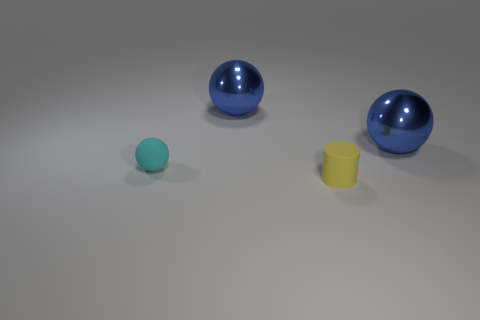There is a thing that is both behind the small cyan matte sphere and to the left of the small matte cylinder; what is it made of?
Your answer should be compact. Metal. Do the object in front of the cyan object and the cyan rubber ball have the same size?
Offer a very short reply. Yes. Does the matte cylinder have the same color as the small rubber sphere?
Provide a succinct answer. No. What number of objects are both to the left of the cylinder and behind the small cyan object?
Give a very brief answer. 1. What number of big metallic things are in front of the small thing that is in front of the small ball left of the tiny yellow matte cylinder?
Your answer should be compact. 0. The yellow rubber thing has what shape?
Offer a terse response. Cylinder. How many small cyan things are made of the same material as the yellow cylinder?
Provide a short and direct response. 1. There is a object that is the same material as the cylinder; what color is it?
Ensure brevity in your answer.  Cyan. Is the size of the cyan rubber ball the same as the matte thing that is on the right side of the tiny matte sphere?
Your answer should be compact. Yes. There is a blue object to the right of the big thing that is on the left side of the thing that is in front of the small cyan matte sphere; what is its material?
Provide a short and direct response. Metal. 